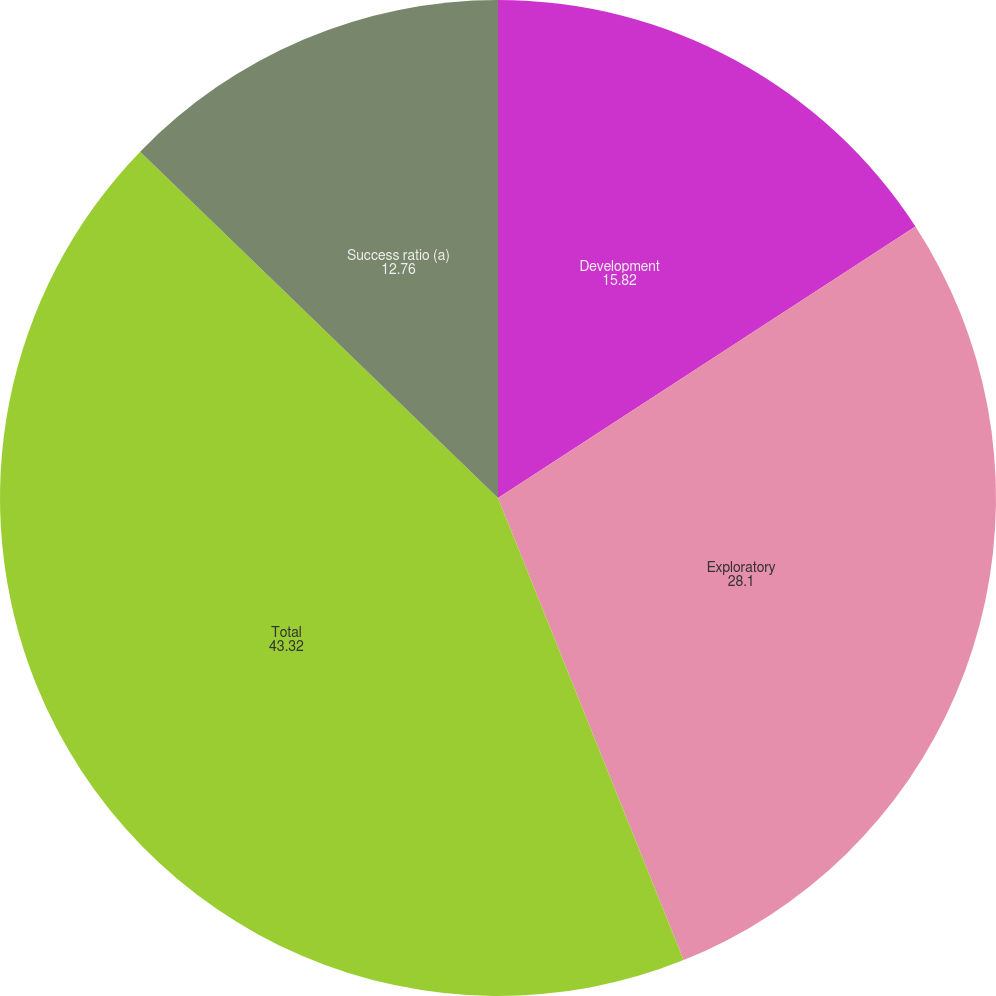<chart> <loc_0><loc_0><loc_500><loc_500><pie_chart><fcel>Development<fcel>Exploratory<fcel>Total<fcel>Success ratio (a)<nl><fcel>15.82%<fcel>28.1%<fcel>43.32%<fcel>12.76%<nl></chart> 